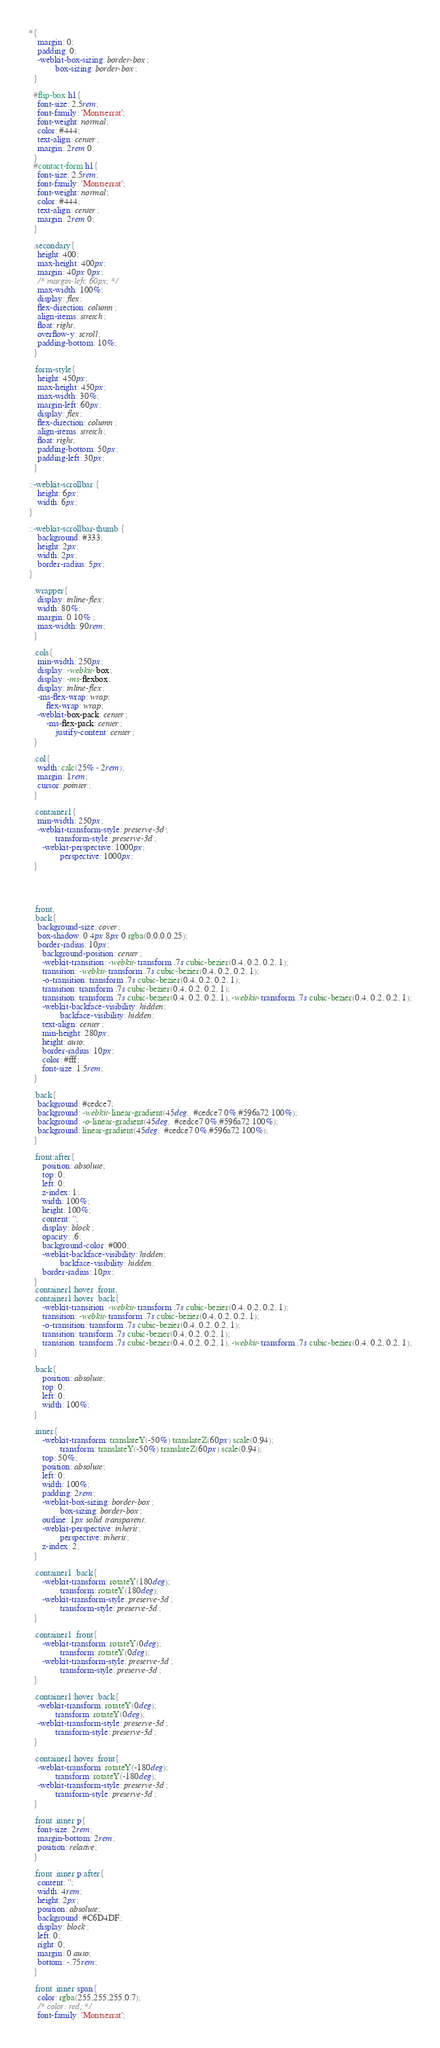<code> <loc_0><loc_0><loc_500><loc_500><_CSS_>*{
    margin: 0;
    padding: 0;
    -webkit-box-sizing: border-box;
            box-sizing: border-box;
  }
  
  #flip-box h1{
    font-size: 2.5rem;
    font-family: 'Montserrat';
    font-weight: normal;
    color: #444;
    text-align: center;
    margin: 2rem 0;
  }
  #contact-form h1{
    font-size: 2.5rem;
    font-family: 'Montserrat';
    font-weight: normal;
    color: #444;
    text-align: center;
    margin: 2rem 0;
  }

  .secondary{
    height: 400;
    max-height: 400px;
    margin: 40px 0px;
    /* margin-left: 60px; */
    max-width: 100%;
    display: flex;
    flex-direction: column;
    align-items: stretch;
    float: right;
    overflow-y: scroll;
    padding-bottom: 10%;
  }

  .form-style{
    height: 450px;
    max-height: 450px;
    max-width: 30%;
    margin-left: 60px;
    display: flex;
    flex-direction: column;
    align-items: stretch;
    float: right;
    padding-bottom: 50px;
    padding-left: 30px;
  }
  
::-webkit-scrollbar {
    height: 6px;
    width: 6px;
}

::-webkit-scrollbar-thumb {
    background: #333; 
    height: 2px;
    width: 2px;
    border-radius: 5px;
}

  .wrapper{
    display: inline-flex;
    width: 80%;
    margin: 0 10% ;
    max-width: 90rem;
  }
  
  .cols{
    min-width: 250px;
    display: -webkit-box;
    display: -ms-flexbox;
    display: inline-flex;
    -ms-flex-wrap: wrap;
        flex-wrap: wrap;
    -webkit-box-pack: center;
        -ms-flex-pack: center;
            justify-content: center;
  }
  
  .col{
    width: calc(25% - 2rem);
    margin: 1rem;
    cursor: pointer;
  }
  
  .container1{
    min-width: 250px;
    -webkit-transform-style: preserve-3d;
            transform-style: preserve-3d;
      -webkit-perspective: 1000px;
              perspective: 1000px;
  }



  
  .front,
  .back{
    background-size: cover;
    box-shadow: 0 4px 8px 0 rgba(0,0,0,0.25);
    border-radius: 10px;
      background-position: center;
      -webkit-transition: -webkit-transform .7s cubic-bezier(0.4, 0.2, 0.2, 1);
      transition: -webkit-transform .7s cubic-bezier(0.4, 0.2, 0.2, 1);
      -o-transition: transform .7s cubic-bezier(0.4, 0.2, 0.2, 1);
      transition: transform .7s cubic-bezier(0.4, 0.2, 0.2, 1);
      transition: transform .7s cubic-bezier(0.4, 0.2, 0.2, 1), -webkit-transform .7s cubic-bezier(0.4, 0.2, 0.2, 1);
      -webkit-backface-visibility: hidden;
              backface-visibility: hidden;
      text-align: center;
      min-height: 280px;
      height: auto;
      border-radius: 10px;
      color: #fff;
      font-size: 1.5rem;
  }
  
  .back{
    background: #cedce7;
    background: -webkit-linear-gradient(45deg,  #cedce7 0%,#596a72 100%);
    background: -o-linear-gradient(45deg,  #cedce7 0%,#596a72 100%);
    background: linear-gradient(45deg,  #cedce7 0%,#596a72 100%);
  }
  
  .front:after{
      position: absolute;
      top: 0;
      left: 0;
      z-index: 1;
      width: 100%;
      height: 100%;
      content: '';
      display: block;
      opacity: .6;
      background-color: #000;
      -webkit-backface-visibility: hidden;
              backface-visibility: hidden;
      border-radius: 10px;
  }
  .container1:hover .front,
  .container1:hover .back{
      -webkit-transition: -webkit-transform .7s cubic-bezier(0.4, 0.2, 0.2, 1);
      transition: -webkit-transform .7s cubic-bezier(0.4, 0.2, 0.2, 1);
      -o-transition: transform .7s cubic-bezier(0.4, 0.2, 0.2, 1);
      transition: transform .7s cubic-bezier(0.4, 0.2, 0.2, 1);
      transition: transform .7s cubic-bezier(0.4, 0.2, 0.2, 1), -webkit-transform .7s cubic-bezier(0.4, 0.2, 0.2, 1);
  }
  
  .back{
      position: absolute;
      top: 0;
      left: 0;
      width: 100%;
  }
  
  .inner{
      -webkit-transform: translateY(-50%) translateZ(60px) scale(0.94);
              transform: translateY(-50%) translateZ(60px) scale(0.94);
      top: 50%;
      position: absolute;
      left: 0;
      width: 100%;
      padding: 2rem;
      -webkit-box-sizing: border-box;
              box-sizing: border-box;
      outline: 1px solid transparent;
      -webkit-perspective: inherit;
              perspective: inherit;
      z-index: 2;
  }
  
  .container1 .back{
      -webkit-transform: rotateY(180deg);
              transform: rotateY(180deg);
      -webkit-transform-style: preserve-3d;
              transform-style: preserve-3d;
  }
  
  .container1 .front{
      -webkit-transform: rotateY(0deg);
              transform: rotateY(0deg);
      -webkit-transform-style: preserve-3d;
              transform-style: preserve-3d;
  }
  
  .container1:hover .back{
    -webkit-transform: rotateY(0deg);
            transform: rotateY(0deg);
    -webkit-transform-style: preserve-3d;
            transform-style: preserve-3d;
  }
  
  .container1:hover .front{
    -webkit-transform: rotateY(-180deg);
            transform: rotateY(-180deg);
    -webkit-transform-style: preserve-3d;
            transform-style: preserve-3d;
  }
  
  .front .inner p{
    font-size: 2rem;
    margin-bottom: 2rem;
    position: relative;
  }
  
  .front .inner p:after{
    content: '';
    width: 4rem;
    height: 2px;
    position: absolute;
    background: #C6D4DF;
    display: block;
    left: 0;
    right: 0;
    margin: 0 auto;
    bottom: -.75rem;
  }
  
  .front .inner span{
    color: rgba(255,255,255,0.7);
    /* color: red; */
    font-family: 'Montserrat';</code> 